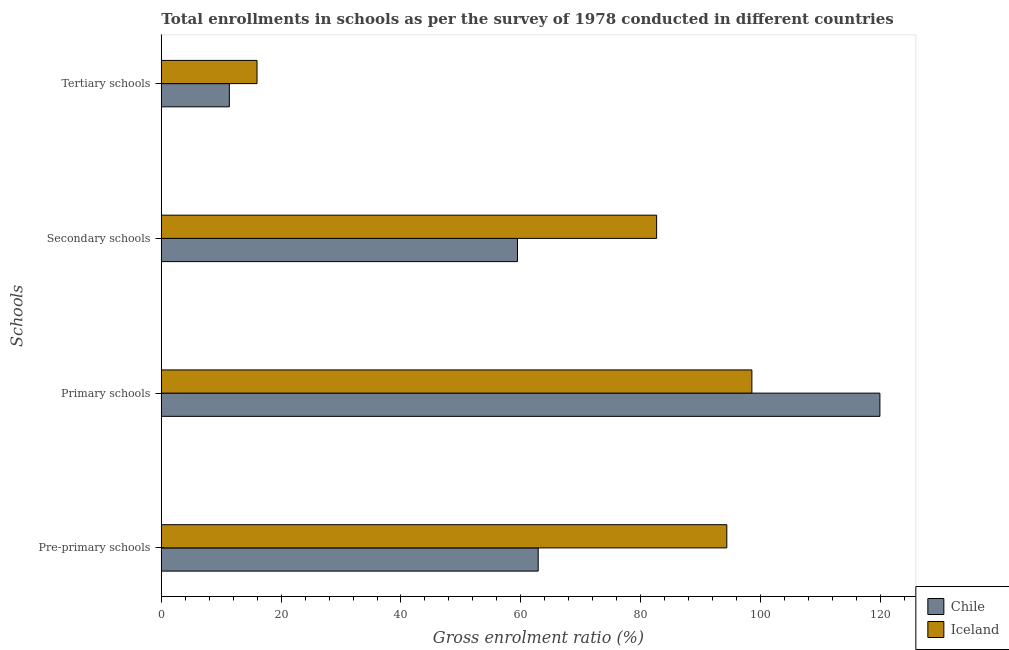How many groups of bars are there?
Provide a short and direct response. 4. How many bars are there on the 1st tick from the bottom?
Offer a very short reply. 2. What is the label of the 2nd group of bars from the top?
Ensure brevity in your answer.  Secondary schools. What is the gross enrolment ratio in tertiary schools in Iceland?
Give a very brief answer. 15.98. Across all countries, what is the maximum gross enrolment ratio in primary schools?
Your answer should be very brief. 119.93. Across all countries, what is the minimum gross enrolment ratio in pre-primary schools?
Offer a very short reply. 62.9. In which country was the gross enrolment ratio in tertiary schools maximum?
Make the answer very short. Iceland. What is the total gross enrolment ratio in primary schools in the graph?
Give a very brief answer. 218.49. What is the difference between the gross enrolment ratio in secondary schools in Iceland and that in Chile?
Offer a terse response. 23.22. What is the difference between the gross enrolment ratio in secondary schools in Chile and the gross enrolment ratio in tertiary schools in Iceland?
Keep it short and to the point. 43.47. What is the average gross enrolment ratio in pre-primary schools per country?
Your answer should be very brief. 78.64. What is the difference between the gross enrolment ratio in secondary schools and gross enrolment ratio in primary schools in Chile?
Your response must be concise. -60.49. In how many countries, is the gross enrolment ratio in primary schools greater than 40 %?
Provide a succinct answer. 2. What is the ratio of the gross enrolment ratio in primary schools in Chile to that in Iceland?
Keep it short and to the point. 1.22. What is the difference between the highest and the second highest gross enrolment ratio in pre-primary schools?
Your answer should be compact. 31.48. What is the difference between the highest and the lowest gross enrolment ratio in primary schools?
Your answer should be compact. 21.36. Is the sum of the gross enrolment ratio in tertiary schools in Chile and Iceland greater than the maximum gross enrolment ratio in pre-primary schools across all countries?
Your answer should be very brief. No. What does the 2nd bar from the top in Primary schools represents?
Offer a terse response. Chile. How many bars are there?
Offer a terse response. 8. Are the values on the major ticks of X-axis written in scientific E-notation?
Ensure brevity in your answer.  No. How are the legend labels stacked?
Make the answer very short. Vertical. What is the title of the graph?
Your response must be concise. Total enrollments in schools as per the survey of 1978 conducted in different countries. What is the label or title of the X-axis?
Provide a short and direct response. Gross enrolment ratio (%). What is the label or title of the Y-axis?
Your answer should be compact. Schools. What is the Gross enrolment ratio (%) in Chile in Pre-primary schools?
Offer a terse response. 62.9. What is the Gross enrolment ratio (%) of Iceland in Pre-primary schools?
Your response must be concise. 94.38. What is the Gross enrolment ratio (%) in Chile in Primary schools?
Your answer should be compact. 119.93. What is the Gross enrolment ratio (%) of Iceland in Primary schools?
Provide a short and direct response. 98.56. What is the Gross enrolment ratio (%) of Chile in Secondary schools?
Your answer should be compact. 59.44. What is the Gross enrolment ratio (%) in Iceland in Secondary schools?
Give a very brief answer. 82.66. What is the Gross enrolment ratio (%) in Chile in Tertiary schools?
Provide a succinct answer. 11.35. What is the Gross enrolment ratio (%) in Iceland in Tertiary schools?
Your answer should be very brief. 15.98. Across all Schools, what is the maximum Gross enrolment ratio (%) of Chile?
Provide a succinct answer. 119.93. Across all Schools, what is the maximum Gross enrolment ratio (%) in Iceland?
Your answer should be very brief. 98.56. Across all Schools, what is the minimum Gross enrolment ratio (%) of Chile?
Offer a very short reply. 11.35. Across all Schools, what is the minimum Gross enrolment ratio (%) in Iceland?
Ensure brevity in your answer.  15.98. What is the total Gross enrolment ratio (%) in Chile in the graph?
Provide a short and direct response. 253.62. What is the total Gross enrolment ratio (%) of Iceland in the graph?
Offer a terse response. 291.58. What is the difference between the Gross enrolment ratio (%) of Chile in Pre-primary schools and that in Primary schools?
Offer a very short reply. -57.03. What is the difference between the Gross enrolment ratio (%) in Iceland in Pre-primary schools and that in Primary schools?
Give a very brief answer. -4.19. What is the difference between the Gross enrolment ratio (%) in Chile in Pre-primary schools and that in Secondary schools?
Provide a short and direct response. 3.46. What is the difference between the Gross enrolment ratio (%) in Iceland in Pre-primary schools and that in Secondary schools?
Your response must be concise. 11.72. What is the difference between the Gross enrolment ratio (%) of Chile in Pre-primary schools and that in Tertiary schools?
Your answer should be very brief. 51.55. What is the difference between the Gross enrolment ratio (%) in Iceland in Pre-primary schools and that in Tertiary schools?
Your response must be concise. 78.4. What is the difference between the Gross enrolment ratio (%) in Chile in Primary schools and that in Secondary schools?
Your response must be concise. 60.49. What is the difference between the Gross enrolment ratio (%) in Iceland in Primary schools and that in Secondary schools?
Make the answer very short. 15.9. What is the difference between the Gross enrolment ratio (%) of Chile in Primary schools and that in Tertiary schools?
Your response must be concise. 108.58. What is the difference between the Gross enrolment ratio (%) of Iceland in Primary schools and that in Tertiary schools?
Offer a very short reply. 82.59. What is the difference between the Gross enrolment ratio (%) of Chile in Secondary schools and that in Tertiary schools?
Offer a terse response. 48.09. What is the difference between the Gross enrolment ratio (%) of Iceland in Secondary schools and that in Tertiary schools?
Offer a very short reply. 66.69. What is the difference between the Gross enrolment ratio (%) of Chile in Pre-primary schools and the Gross enrolment ratio (%) of Iceland in Primary schools?
Your answer should be compact. -35.66. What is the difference between the Gross enrolment ratio (%) of Chile in Pre-primary schools and the Gross enrolment ratio (%) of Iceland in Secondary schools?
Offer a terse response. -19.76. What is the difference between the Gross enrolment ratio (%) of Chile in Pre-primary schools and the Gross enrolment ratio (%) of Iceland in Tertiary schools?
Keep it short and to the point. 46.93. What is the difference between the Gross enrolment ratio (%) in Chile in Primary schools and the Gross enrolment ratio (%) in Iceland in Secondary schools?
Give a very brief answer. 37.27. What is the difference between the Gross enrolment ratio (%) in Chile in Primary schools and the Gross enrolment ratio (%) in Iceland in Tertiary schools?
Make the answer very short. 103.95. What is the difference between the Gross enrolment ratio (%) in Chile in Secondary schools and the Gross enrolment ratio (%) in Iceland in Tertiary schools?
Make the answer very short. 43.47. What is the average Gross enrolment ratio (%) in Chile per Schools?
Provide a short and direct response. 63.41. What is the average Gross enrolment ratio (%) in Iceland per Schools?
Make the answer very short. 72.89. What is the difference between the Gross enrolment ratio (%) of Chile and Gross enrolment ratio (%) of Iceland in Pre-primary schools?
Offer a very short reply. -31.48. What is the difference between the Gross enrolment ratio (%) in Chile and Gross enrolment ratio (%) in Iceland in Primary schools?
Your response must be concise. 21.36. What is the difference between the Gross enrolment ratio (%) in Chile and Gross enrolment ratio (%) in Iceland in Secondary schools?
Your answer should be compact. -23.22. What is the difference between the Gross enrolment ratio (%) of Chile and Gross enrolment ratio (%) of Iceland in Tertiary schools?
Provide a succinct answer. -4.62. What is the ratio of the Gross enrolment ratio (%) of Chile in Pre-primary schools to that in Primary schools?
Keep it short and to the point. 0.52. What is the ratio of the Gross enrolment ratio (%) of Iceland in Pre-primary schools to that in Primary schools?
Your response must be concise. 0.96. What is the ratio of the Gross enrolment ratio (%) of Chile in Pre-primary schools to that in Secondary schools?
Your response must be concise. 1.06. What is the ratio of the Gross enrolment ratio (%) of Iceland in Pre-primary schools to that in Secondary schools?
Provide a short and direct response. 1.14. What is the ratio of the Gross enrolment ratio (%) of Chile in Pre-primary schools to that in Tertiary schools?
Offer a very short reply. 5.54. What is the ratio of the Gross enrolment ratio (%) in Iceland in Pre-primary schools to that in Tertiary schools?
Give a very brief answer. 5.91. What is the ratio of the Gross enrolment ratio (%) of Chile in Primary schools to that in Secondary schools?
Make the answer very short. 2.02. What is the ratio of the Gross enrolment ratio (%) in Iceland in Primary schools to that in Secondary schools?
Ensure brevity in your answer.  1.19. What is the ratio of the Gross enrolment ratio (%) of Chile in Primary schools to that in Tertiary schools?
Offer a very short reply. 10.56. What is the ratio of the Gross enrolment ratio (%) in Iceland in Primary schools to that in Tertiary schools?
Ensure brevity in your answer.  6.17. What is the ratio of the Gross enrolment ratio (%) of Chile in Secondary schools to that in Tertiary schools?
Offer a very short reply. 5.24. What is the ratio of the Gross enrolment ratio (%) in Iceland in Secondary schools to that in Tertiary schools?
Offer a terse response. 5.17. What is the difference between the highest and the second highest Gross enrolment ratio (%) of Chile?
Your answer should be very brief. 57.03. What is the difference between the highest and the second highest Gross enrolment ratio (%) in Iceland?
Offer a very short reply. 4.19. What is the difference between the highest and the lowest Gross enrolment ratio (%) in Chile?
Keep it short and to the point. 108.58. What is the difference between the highest and the lowest Gross enrolment ratio (%) in Iceland?
Offer a terse response. 82.59. 